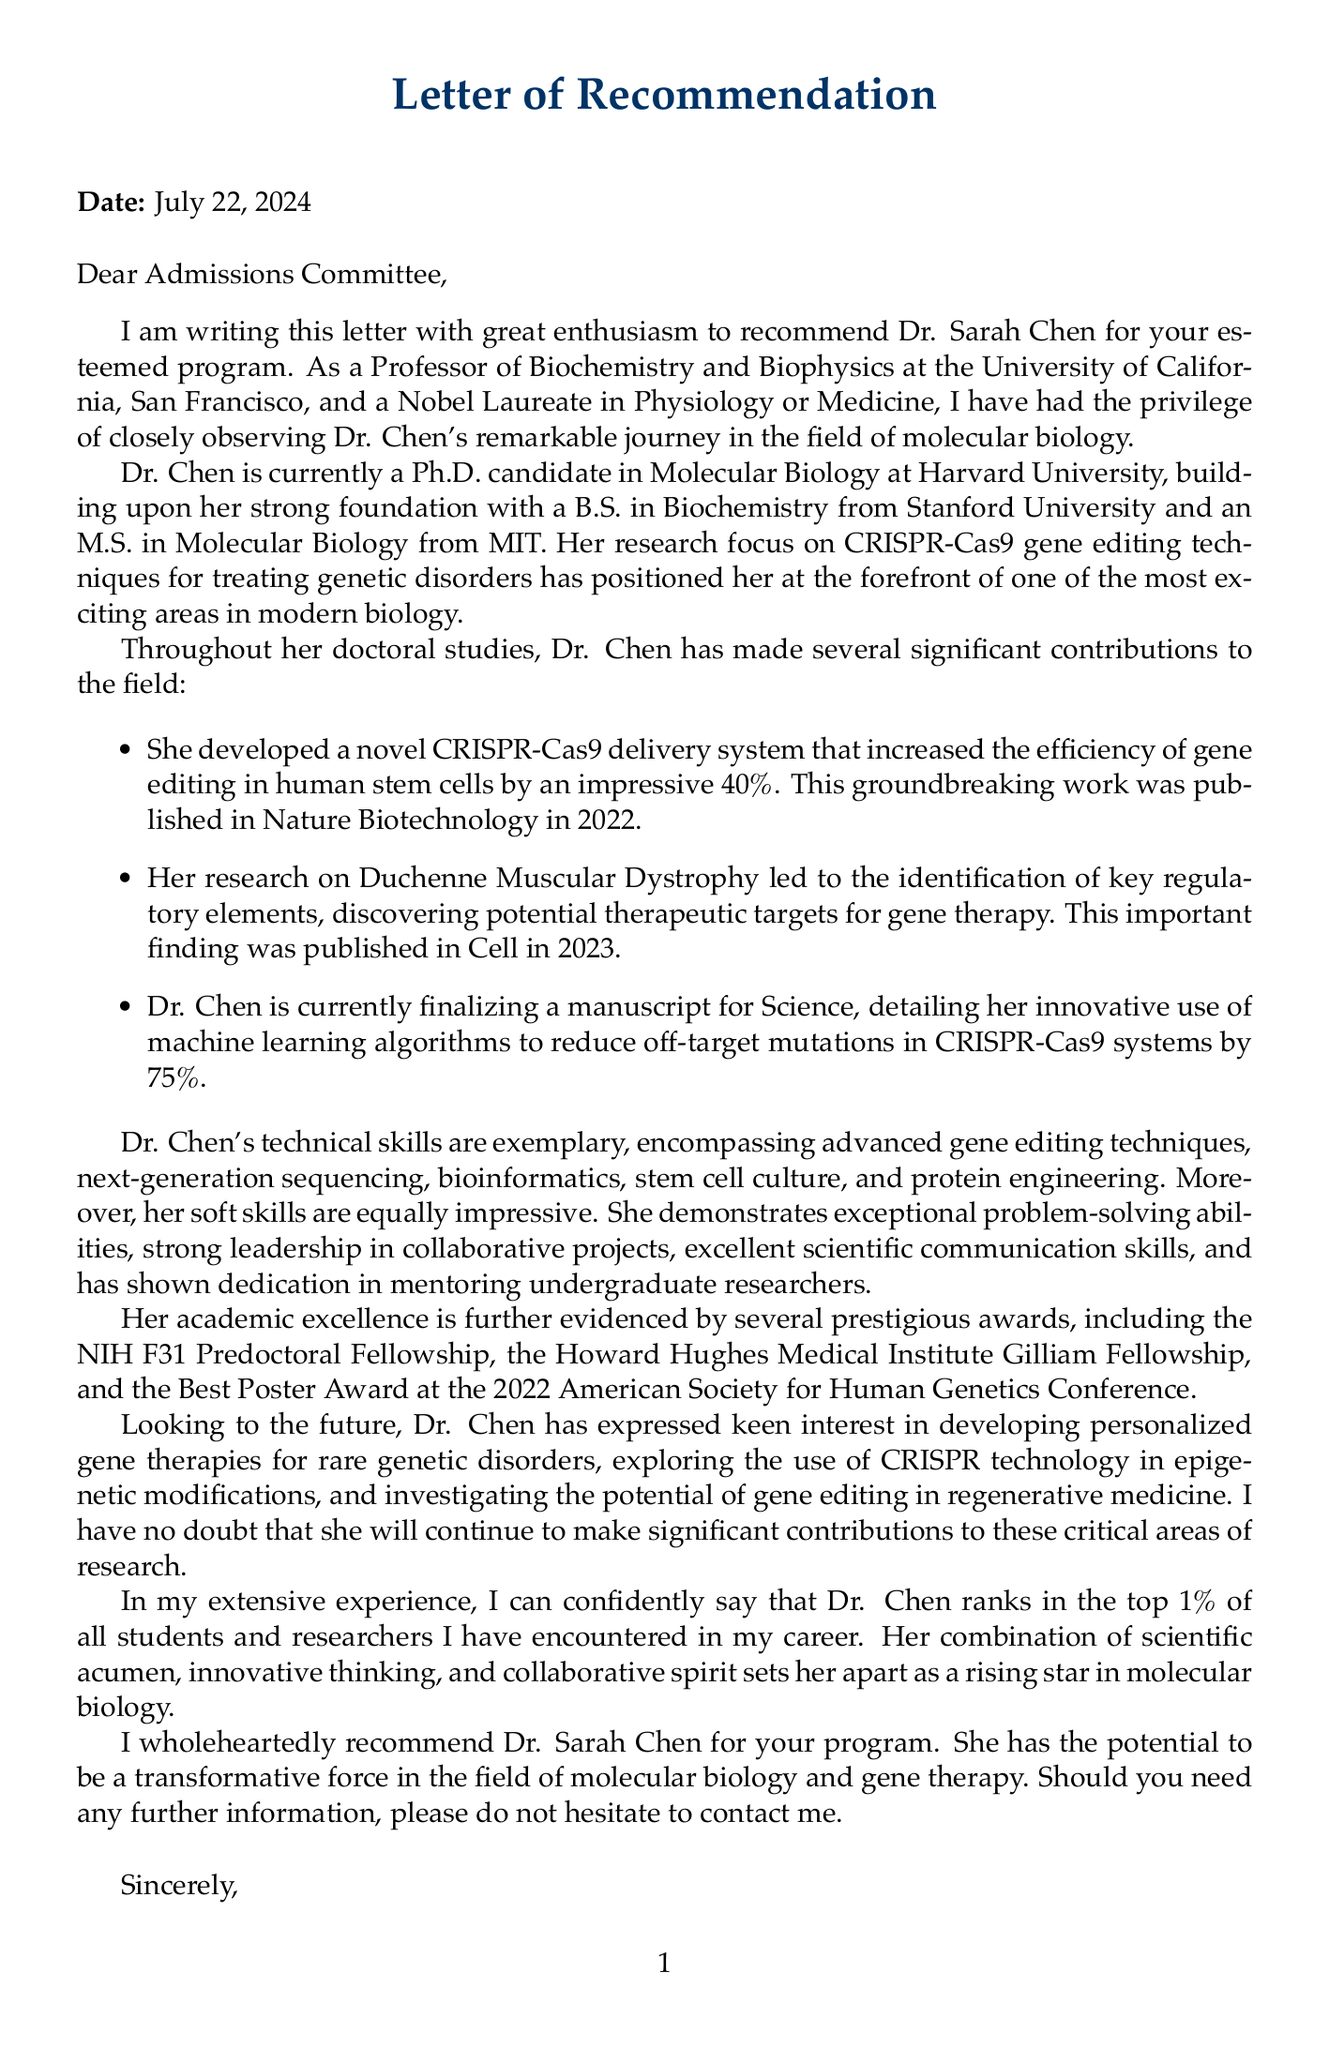What is the candidate's name? The candidate's name is mentioned in the letter's introduction, identifying her as Dr. Sarah Chen.
Answer: Dr. Sarah Chen What is the name of the university where the candidate is currently studying? The document specifies that Dr. Chen is a Ph.D. candidate at Harvard University.
Answer: Harvard University What was the increase in efficiency of the CRISPR-Cas9 delivery system developed by Dr. Chen? The letter states that the delivery system increased gene editing efficiency by 40%.
Answer: 40% What is the title of the manuscript that Dr. Chen is preparing for submission? The document mentions that Dr. Chen's manuscript is intended for submission to the journal Science.
Answer: Science Which prestigious award did Dr. Chen receive for her predoctoral studies? The letter highlights that Dr. Chen received the NIH F31 Predoctoral Fellowship.
Answer: NIH F31 Predoctoral Fellowship What is one of Dr. Chen's future research interests mentioned in the letter? The letter outlines her interest in developing personalized gene therapies for rare genetic disorders.
Answer: Developing personalized gene therapies for rare genetic disorders What percentage of reduction in off-target mutations did Dr. Chen achieve using machine learning algorithms? The letter reports that she reduced off-target mutations by 75%.
Answer: 75% How does the recommender rank Dr. Chen among students and researchers? The letter indicates that Dr. Chen ranks in the top 1% of all students and researchers encountered by the recommender.
Answer: Top 1% What position does Dr. Elizabeth Blackburn hold? The document states that Dr. Blackburn is a Professor of Biochemistry and Biophysics.
Answer: Professor of Biochemistry and Biophysics 